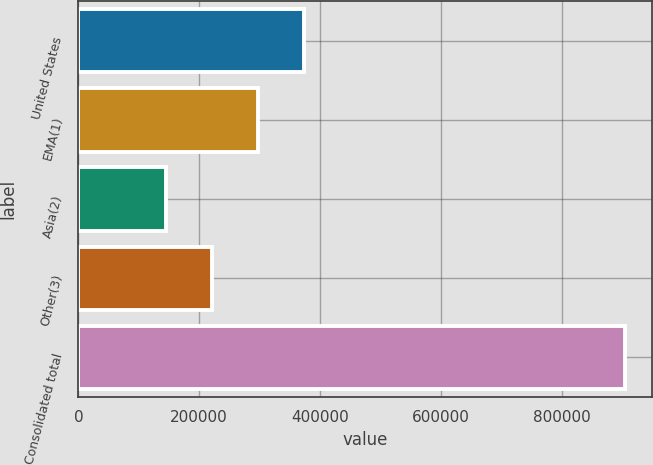Convert chart to OTSL. <chart><loc_0><loc_0><loc_500><loc_500><bar_chart><fcel>United States<fcel>EMA(1)<fcel>Asia(2)<fcel>Other(3)<fcel>Consolidated total<nl><fcel>372612<fcel>296608<fcel>144599<fcel>220603<fcel>904642<nl></chart> 